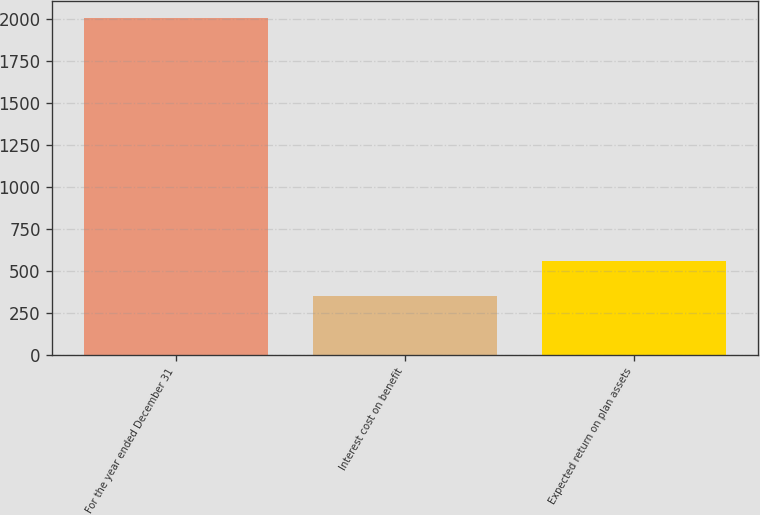<chart> <loc_0><loc_0><loc_500><loc_500><bar_chart><fcel>For the year ended December 31<fcel>Interest cost on benefit<fcel>Expected return on plan assets<nl><fcel>2004<fcel>348<fcel>556<nl></chart> 